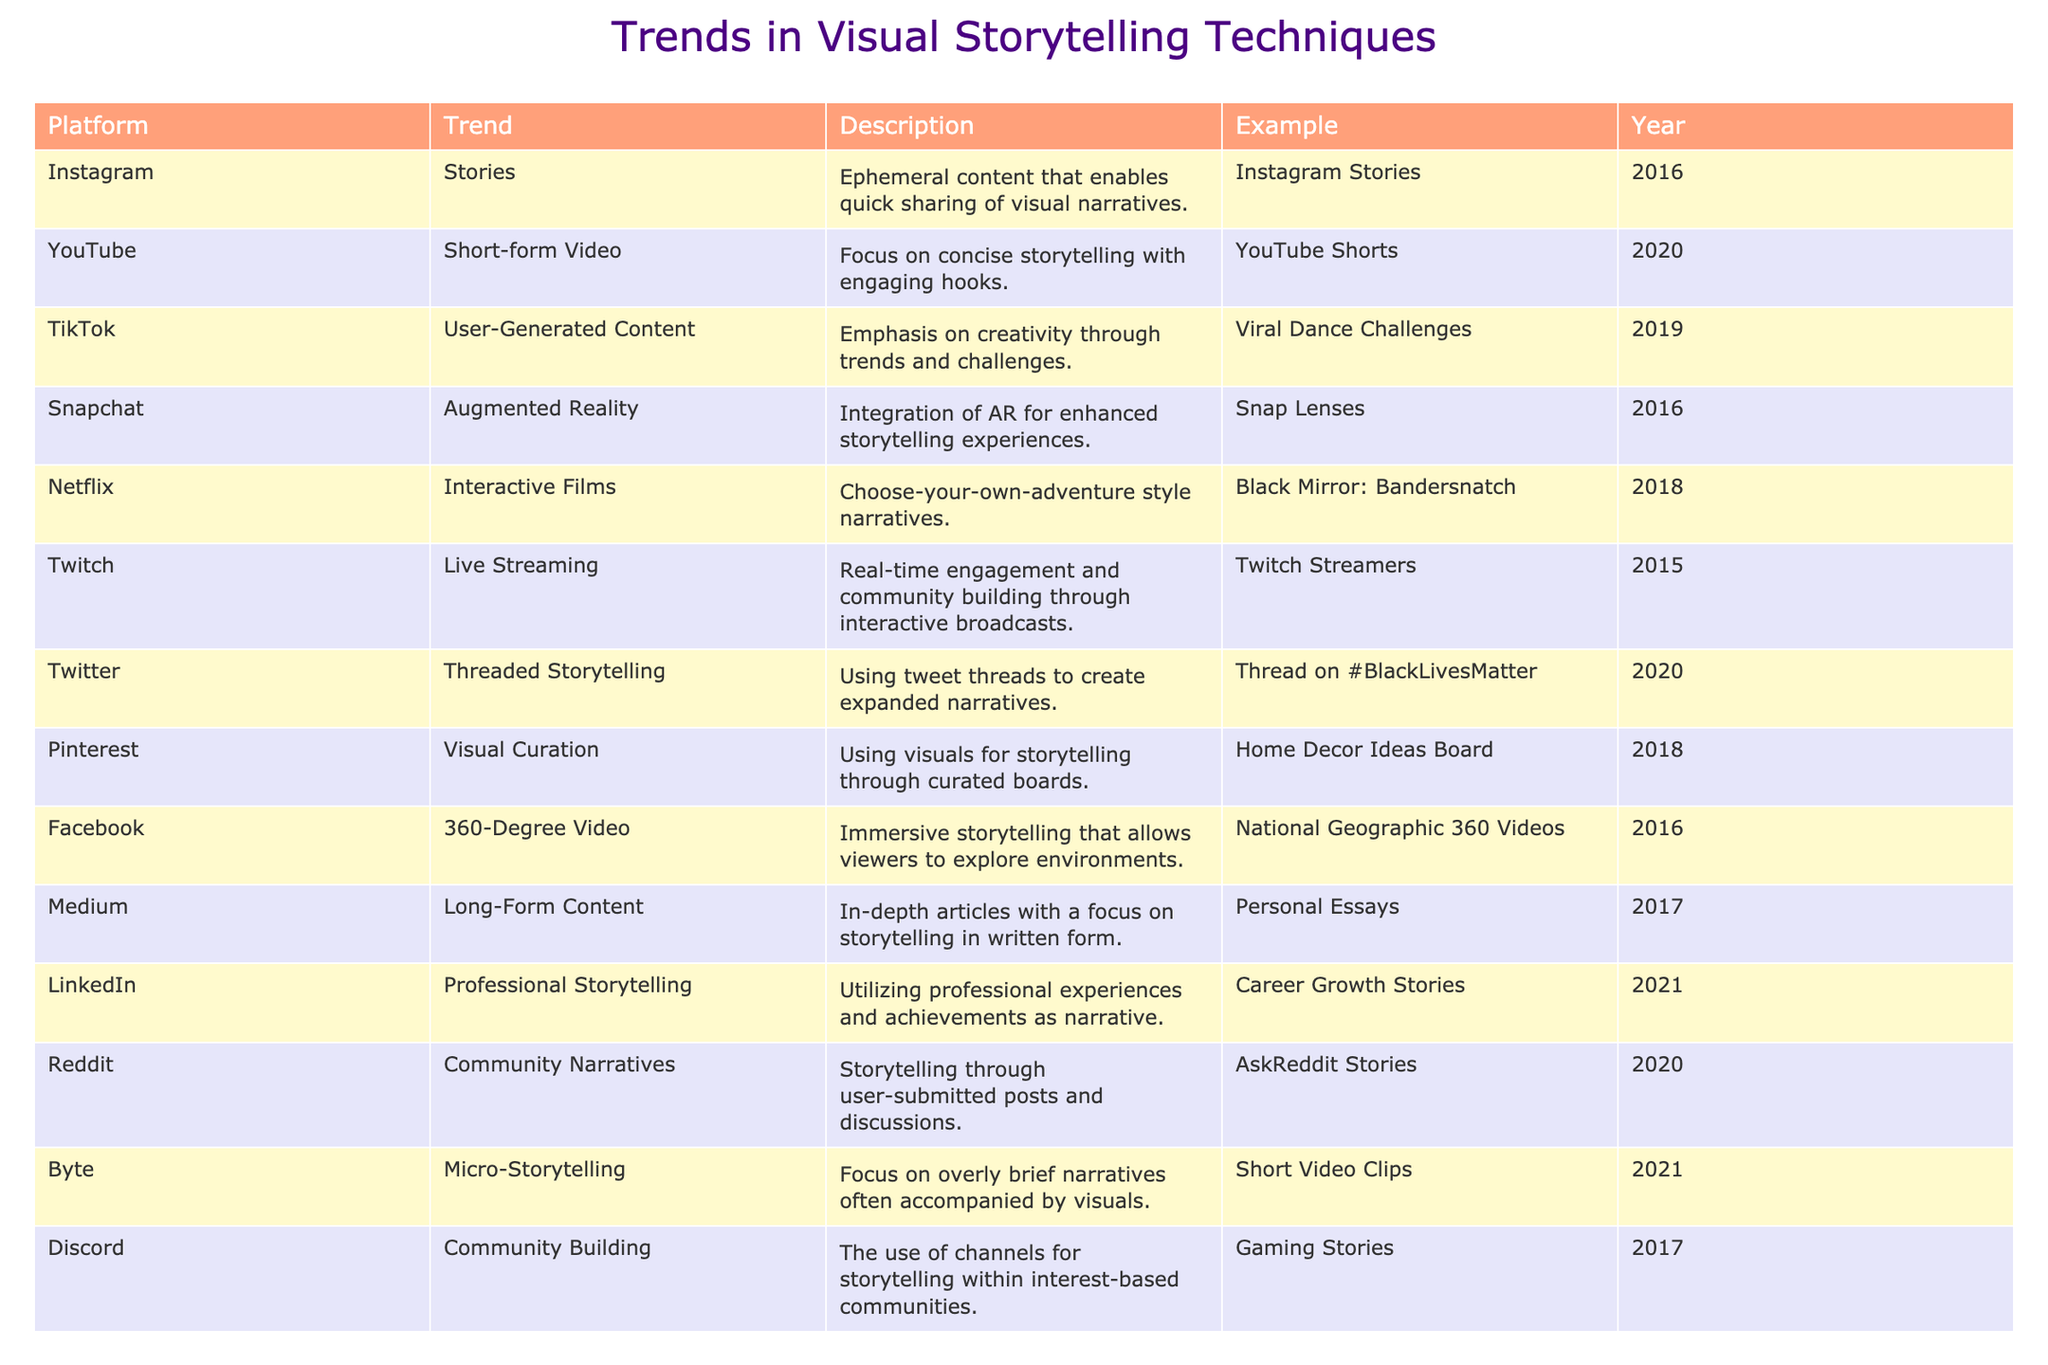What is the trend introduced by Instagram in 2016? The table indicates that Instagram introduced the trend of Stories in 2016, which refers to ephemeral content used for quick sharing of visual narratives.
Answer: Stories Which platform focuses on interactive films and in which year was it introduced? The table shows that Netflix focuses on interactive films, introduced in the year 2018 with the example of "Black Mirror: Bandersnatch."
Answer: Netflix, 2018 Are there any platforms that use augmented reality for storytelling? Yes, Snapchat is noted in the table for using Augmented Reality in their storytelling techniques.
Answer: Yes What platform emphasizes community-building storytelling through user-submitted discussions? The table notes that Reddit emphasizes community narratives through user-submitted posts and discussions, specifically "AskReddit" stories.
Answer: Reddit How many years after Instagram Stories did YouTube Shorts emerge? Instagram Stories was introduced in 2016 and YouTube Shorts in 2020, representing a 4-year gap between their introductions.
Answer: 4 years Which platform introduced a focus on micro-storytelling and when? The table highlights that Byte introduced the trend of micro-storytelling in 2021.
Answer: Byte, 2021 Is there a storytelling technique that combines real-time interaction? If so, which platform is it associated with? Yes, Twitch is associated with the storytelling technique of live streaming, focusing on real-time engagement and community building.
Answer: Yes, Twitch What is the main storytelling format for visual curation found on Pinterest? The table specifies that Pinterest focuses on visual curation, using visuals for storytelling through curated boards like "Home Decor Ideas Board."
Answer: Visual Curation Which platform's storytelling approach was launched in 2017 and emphasizes professional experiences? The table indicates that LinkedIn introduced a professional storytelling approach in 2021, not 2017. Therefore, no platform matches this criteria for 2017.
Answer: None Calculate the total number of trends introduced between 2016 and 2020. The trends introduced during these years are Instagram Stories (2016), Snapchat Augmented Reality (2016), Twitch Live Streaming (2015 but relevant), YouTube Shorts (2020), TikTok User-Generated Content (2019), Twitter Threaded Storytelling (2020), and the total counts to 6 distinct trends introduced or referenced.
Answer: 6 